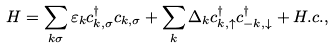Convert formula to latex. <formula><loc_0><loc_0><loc_500><loc_500>H = \sum _ { { k } \sigma } \varepsilon _ { k } c _ { { k } , \sigma } ^ { \dagger } c _ { { k } , \sigma } + \sum _ { k } \Delta _ { k } c _ { { k } , \uparrow } ^ { \dagger } c _ { { - k } , \downarrow } ^ { \dagger } + H . c . ,</formula> 